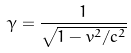Convert formula to latex. <formula><loc_0><loc_0><loc_500><loc_500>\gamma = { \frac { 1 } { \sqrt { 1 - v ^ { 2 } / c ^ { 2 } } } }</formula> 